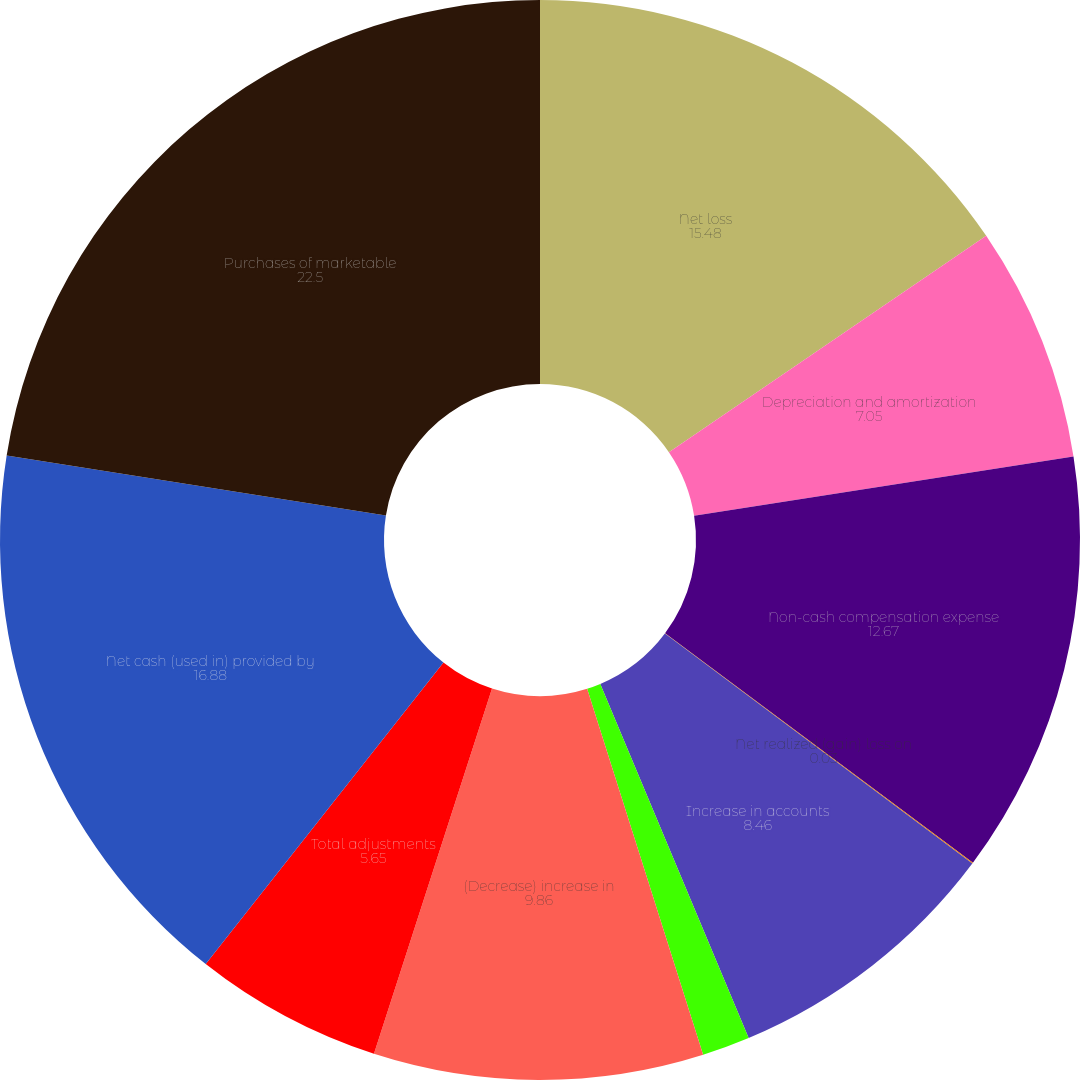Convert chart. <chart><loc_0><loc_0><loc_500><loc_500><pie_chart><fcel>Net loss<fcel>Depreciation and amortization<fcel>Non-cash compensation expense<fcel>Net realized (gain) loss on<fcel>Increase in accounts<fcel>Increase in prepaid expenses<fcel>(Decrease) increase in<fcel>Total adjustments<fcel>Net cash (used in) provided by<fcel>Purchases of marketable<nl><fcel>15.48%<fcel>7.05%<fcel>12.67%<fcel>0.03%<fcel>8.46%<fcel>1.43%<fcel>9.86%<fcel>5.65%<fcel>16.88%<fcel>22.5%<nl></chart> 